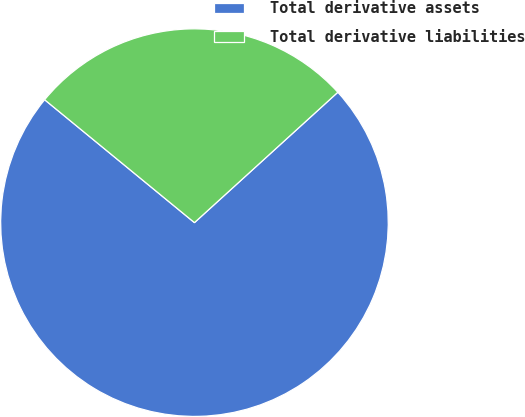Convert chart to OTSL. <chart><loc_0><loc_0><loc_500><loc_500><pie_chart><fcel>Total derivative assets<fcel>Total derivative liabilities<nl><fcel>72.68%<fcel>27.32%<nl></chart> 